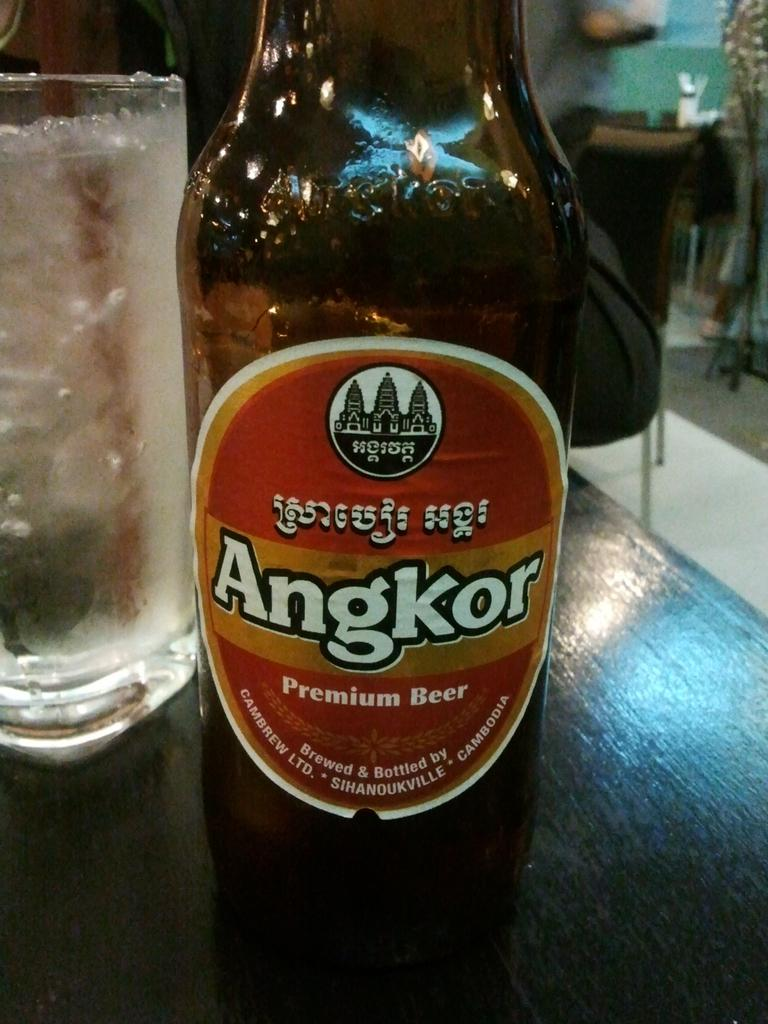What type of beverage container is present in the image? There is a wine bottle in the image. What is the wine bottle accompanied by? There is a glass in the image. Where are the wine bottle and glass located? Both the wine bottle and the glass are on a table. How does the fog affect the taste of the wine in the image? There is no fog present in the image, so it cannot affect the taste of the wine. 